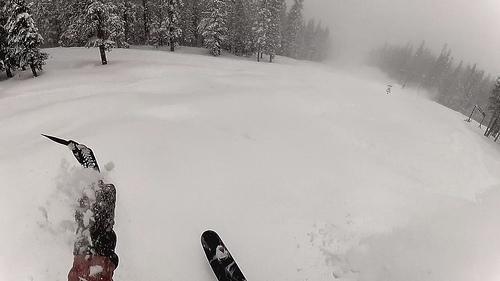How many people ski?
Give a very brief answer. 1. 